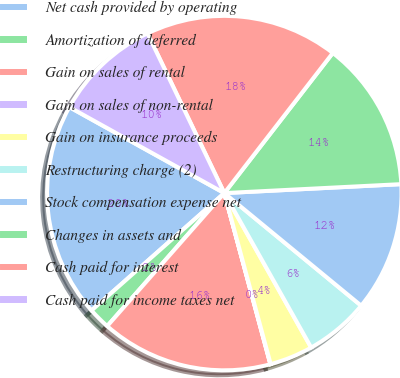<chart> <loc_0><loc_0><loc_500><loc_500><pie_chart><fcel>Net cash provided by operating<fcel>Amortization of deferred<fcel>Gain on sales of rental<fcel>Gain on sales of non-rental<fcel>Gain on insurance proceeds<fcel>Restructuring charge (2)<fcel>Stock compensation expense net<fcel>Changes in assets and<fcel>Cash paid for interest<fcel>Cash paid for income taxes net<nl><fcel>19.58%<fcel>1.99%<fcel>15.67%<fcel>0.03%<fcel>3.94%<fcel>5.89%<fcel>11.76%<fcel>13.71%<fcel>17.62%<fcel>9.8%<nl></chart> 